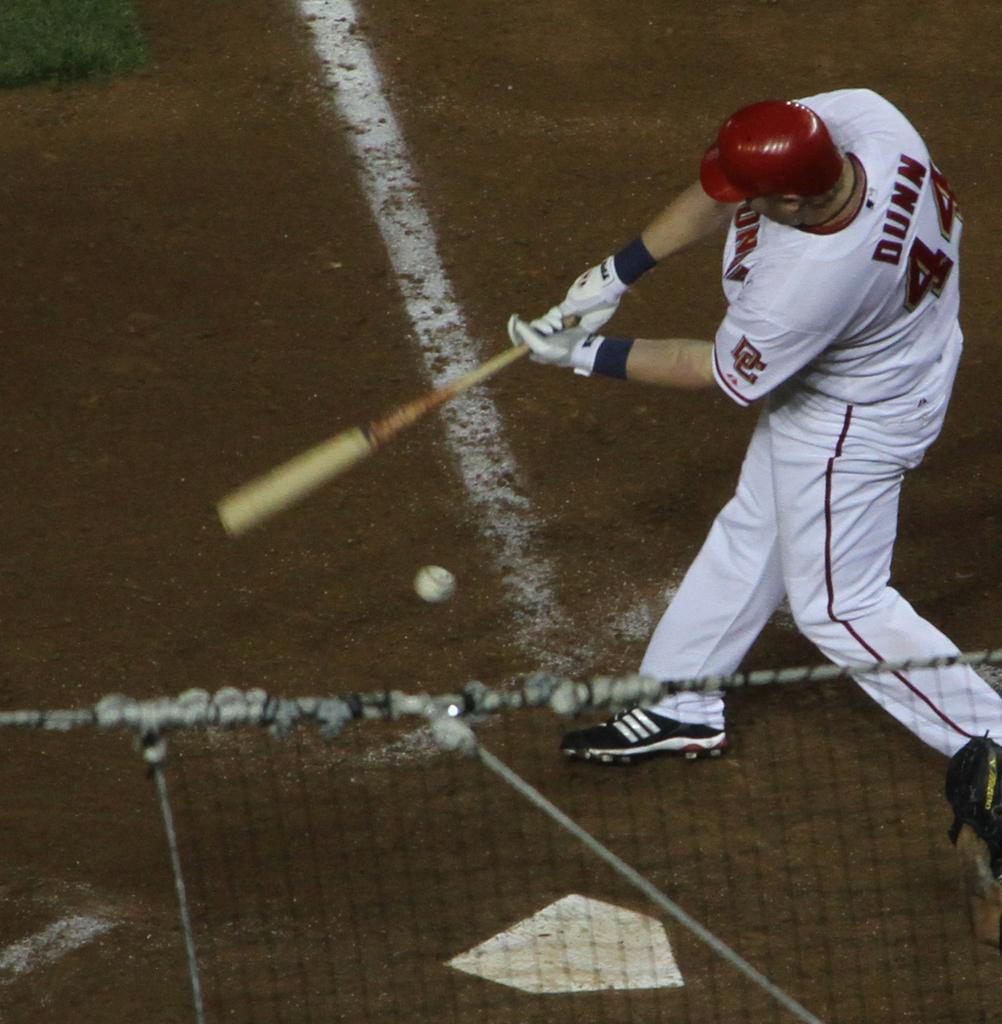<image>
Present a compact description of the photo's key features. Baseball player Dunn is swinging at a ball. 